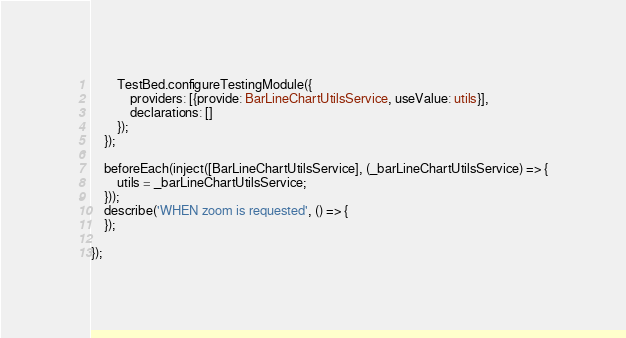<code> <loc_0><loc_0><loc_500><loc_500><_TypeScript_>        TestBed.configureTestingModule({
            providers: [{provide: BarLineChartUtilsService, useValue: utils}],
            declarations: []
        });
    });

    beforeEach(inject([BarLineChartUtilsService], (_barLineChartUtilsService) => {
        utils = _barLineChartUtilsService;
    }));
    describe('WHEN zoom is requested', () => {
    });

});
</code> 